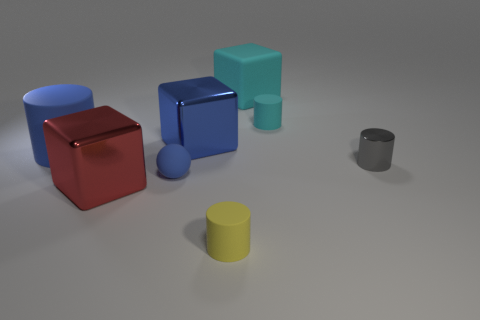Add 1 cyan cubes. How many objects exist? 9 Subtract all cyan cylinders. How many cylinders are left? 3 Subtract all blue cylinders. How many cylinders are left? 3 Subtract 1 cylinders. How many cylinders are left? 3 Add 7 small rubber cylinders. How many small rubber cylinders are left? 9 Add 3 large purple objects. How many large purple objects exist? 3 Subtract 0 brown cylinders. How many objects are left? 8 Subtract all balls. How many objects are left? 7 Subtract all green cylinders. Subtract all gray balls. How many cylinders are left? 4 Subtract all purple balls. How many gray blocks are left? 0 